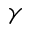Convert formula to latex. <formula><loc_0><loc_0><loc_500><loc_500>\gamma</formula> 